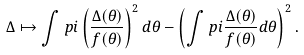Convert formula to latex. <formula><loc_0><loc_0><loc_500><loc_500>\Delta \mapsto \int p i \left ( \frac { \Delta ( \theta ) } { f ( \theta ) } \right ) ^ { 2 } d \theta - \left ( \int p i \frac { \Delta ( \theta ) } { f ( \theta ) } d \theta \right ) ^ { 2 } .</formula> 